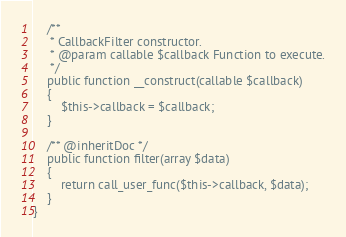<code> <loc_0><loc_0><loc_500><loc_500><_PHP_>    /**
     * CallbackFilter constructor.
     * @param callable $callback Function to execute.
     */
    public function __construct(callable $callback)
    {
        $this->callback = $callback;
    }

    /** @inheritDoc */
    public function filter(array $data)
    {
        return call_user_func($this->callback, $data);
    }
}
</code> 